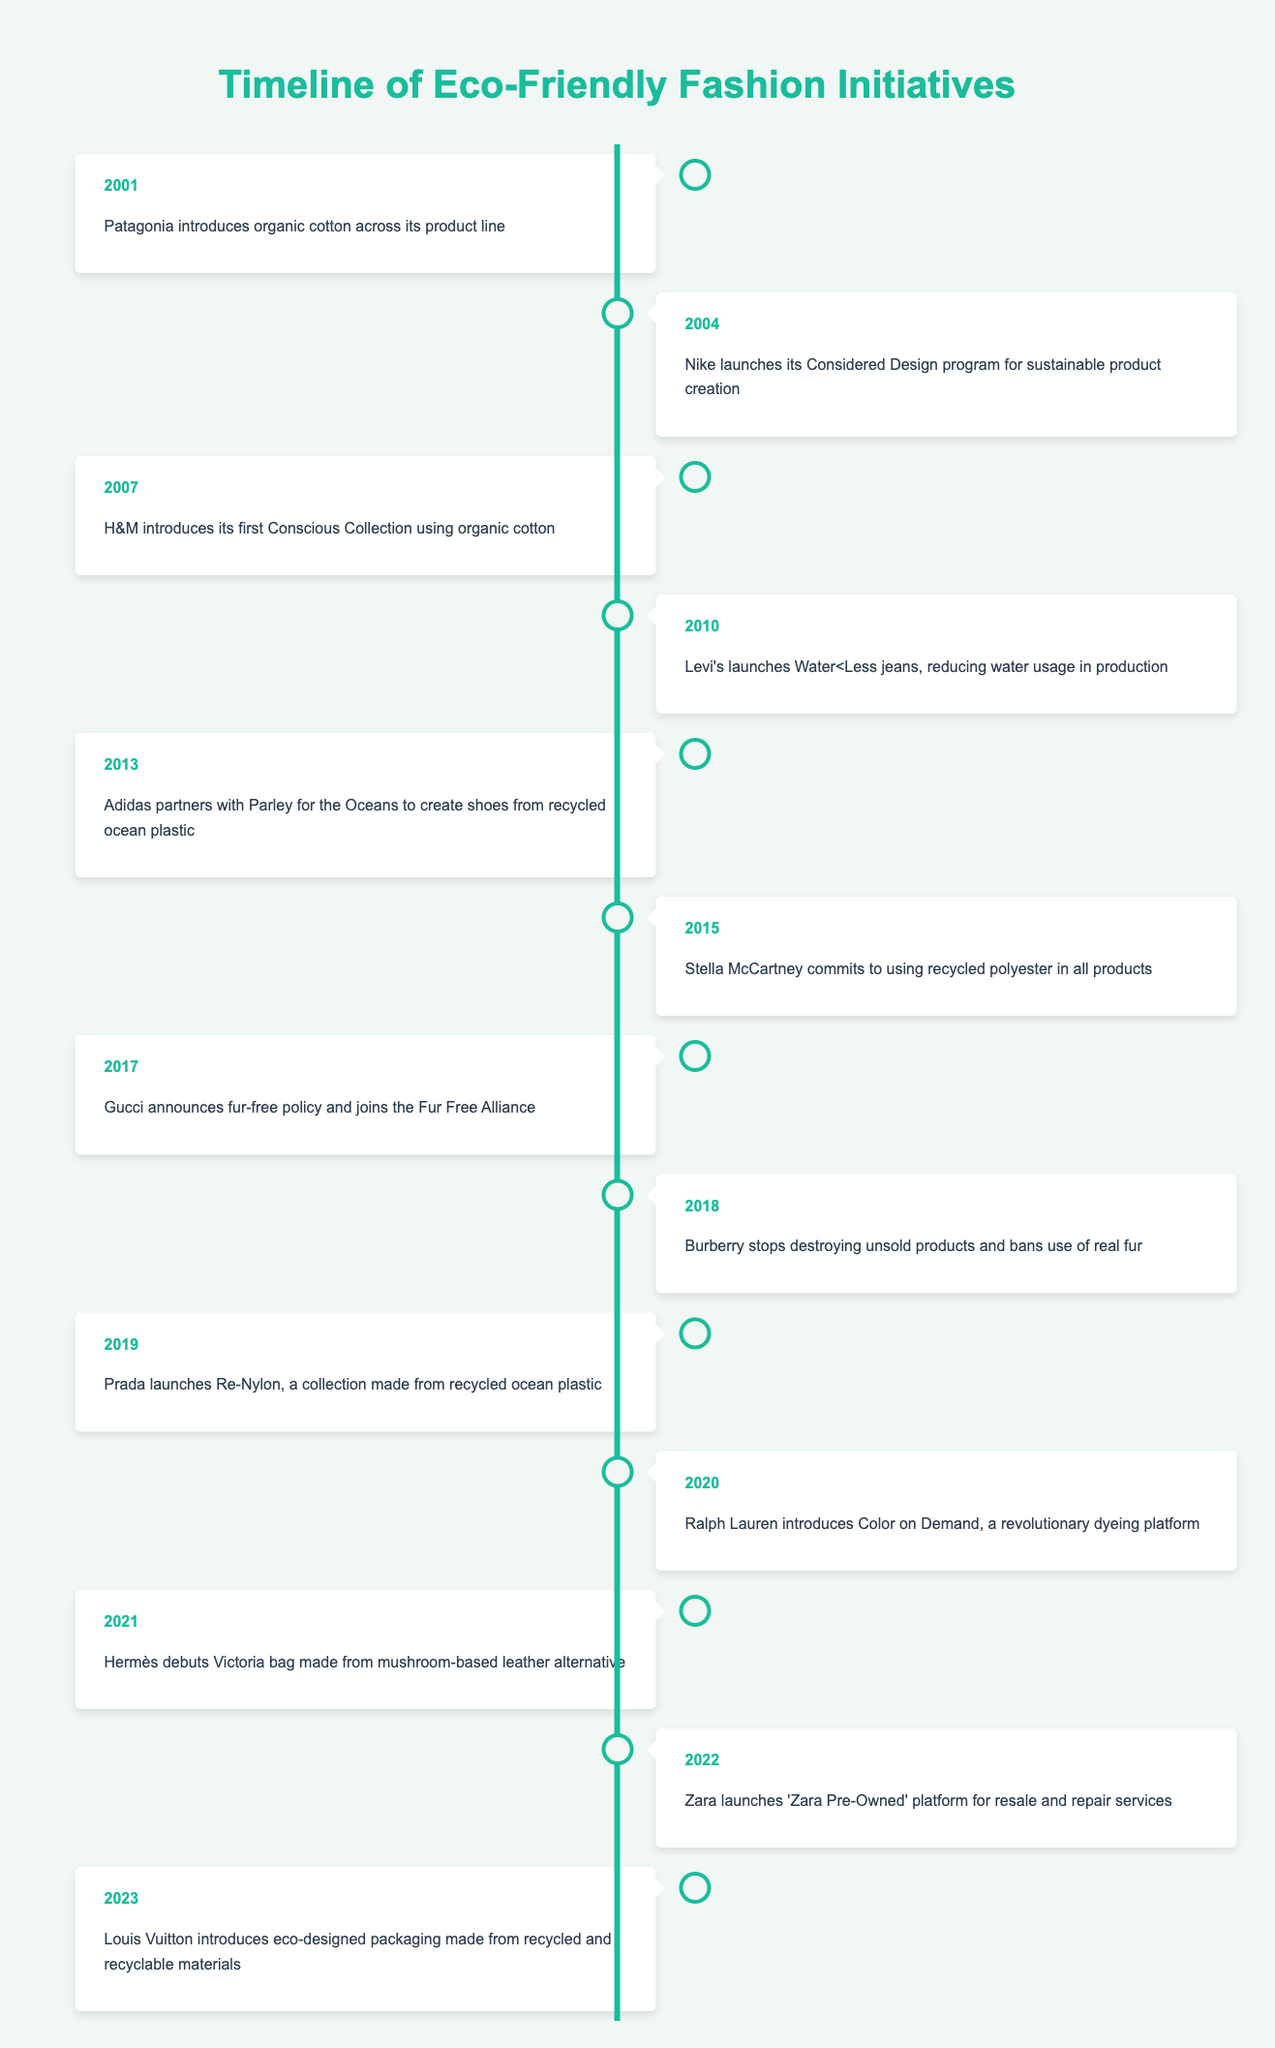What year did Patagonia introduce organic cotton? The table shows that Patagonia introduced organic cotton across its product line in the year 2001.
Answer: 2001 Which brand launched a sustainable design program in 2004? According to the table, Nike launched its Considered Design program for sustainable product creation in 2004.
Answer: Nike How many years passed between H&M's Conscious Collection and the introduction of Ralph Lauren's Color on Demand? H&M's Conscious Collection was introduced in 2007, and Ralph Lauren's Color on Demand was introduced in 2020. Calculating the difference: 2020 - 2007 = 13 years.
Answer: 13 years Did Gucci join the Fur Free Alliance before Burberry stopped using real fur? The table indicates that Gucci announced its fur-free policy and joined the Fur Free Alliance in 2017, while Burberry stopped using real fur in 2018. Thus, Gucci did join the alliance first.
Answer: Yes What percentage of the timeline events mention the use of recycled materials? There are three events mentioning recycled materials: Adidas (2013), Prada (2019), and Hermès (2021). Out of 13 total events, the percentage is (3/13) * 100 = 23.08%.
Answer: 23.08% In which year did two brands make significant changes related to sustainability? Examining the table, two brands made significant changes in 2018 – Burberry stopped destroying unsold products and banned the use of real fur.
Answer: 2018 What is the first brand listed that set a sustainable initiative? The timeline first mentions Patagonia in the year 2001 for introducing organic cotton across its product line.
Answer: Patagonia How many brands introduced initiatives related to water usage or scarcity between 2000 and 2023? The table indicates that Levi's introduced Water<Less jeans in 2010, but does not cite additional initiatives related to water usage. Therefore, there is one brand (Levi's) that introduced initiatives concerning water in that time frame.
Answer: 1 